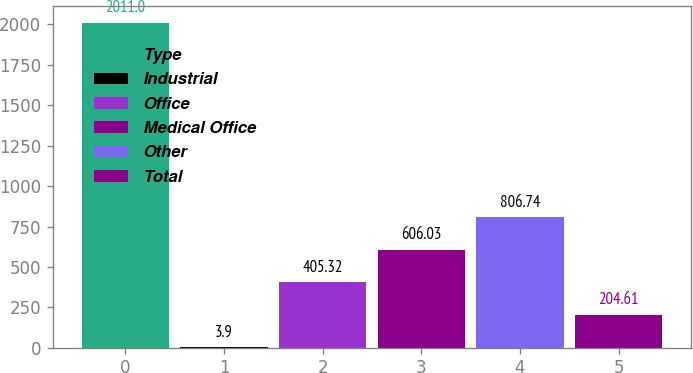Convert chart to OTSL. <chart><loc_0><loc_0><loc_500><loc_500><bar_chart><fcel>Type<fcel>Industrial<fcel>Office<fcel>Medical Office<fcel>Other<fcel>Total<nl><fcel>2011<fcel>3.9<fcel>405.32<fcel>606.03<fcel>806.74<fcel>204.61<nl></chart> 